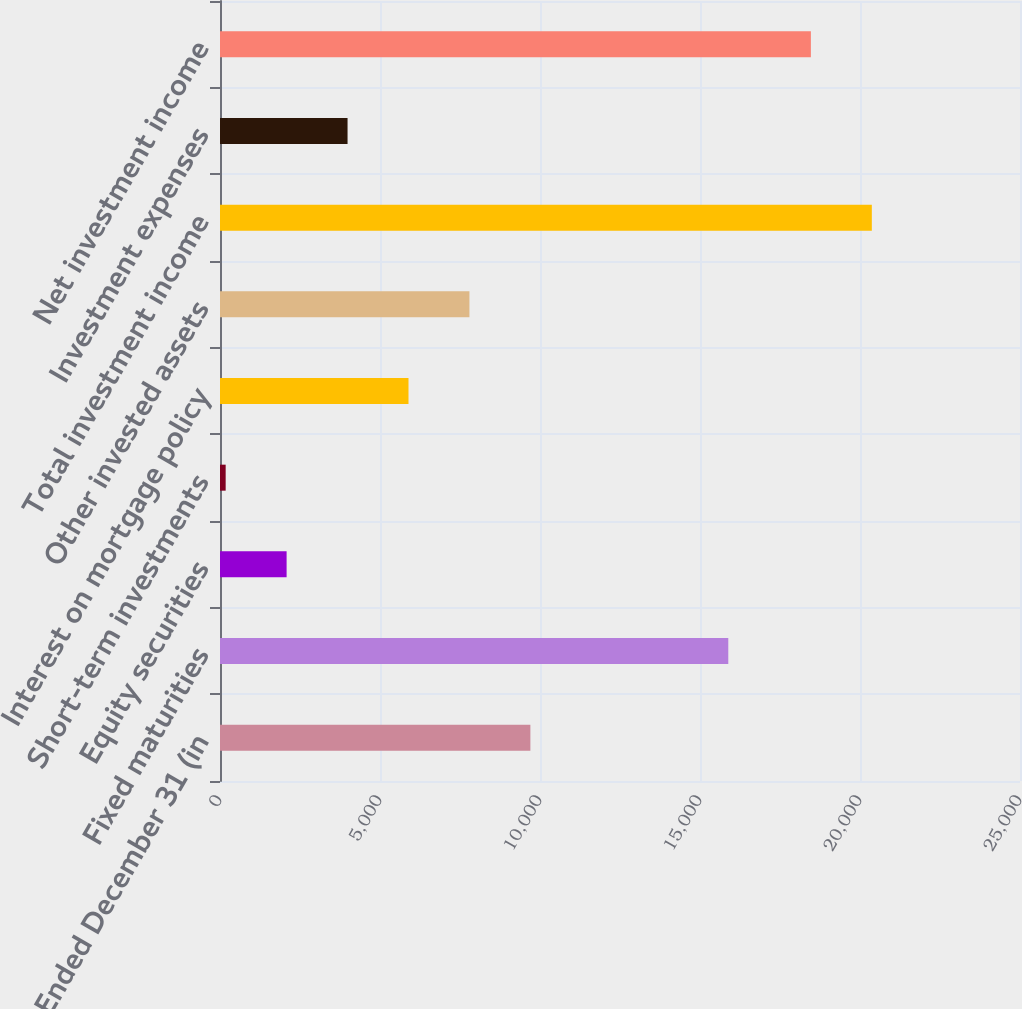Convert chart. <chart><loc_0><loc_0><loc_500><loc_500><bar_chart><fcel>Years Ended December 31 (in<fcel>Fixed maturities<fcel>Equity securities<fcel>Short-term investments<fcel>Interest on mortgage policy<fcel>Other invested assets<fcel>Total investment income<fcel>Investment expenses<fcel>Net investment income<nl><fcel>9699.5<fcel>15884<fcel>2081.5<fcel>177<fcel>5890.5<fcel>7795<fcel>20369.5<fcel>3986<fcel>18465<nl></chart> 